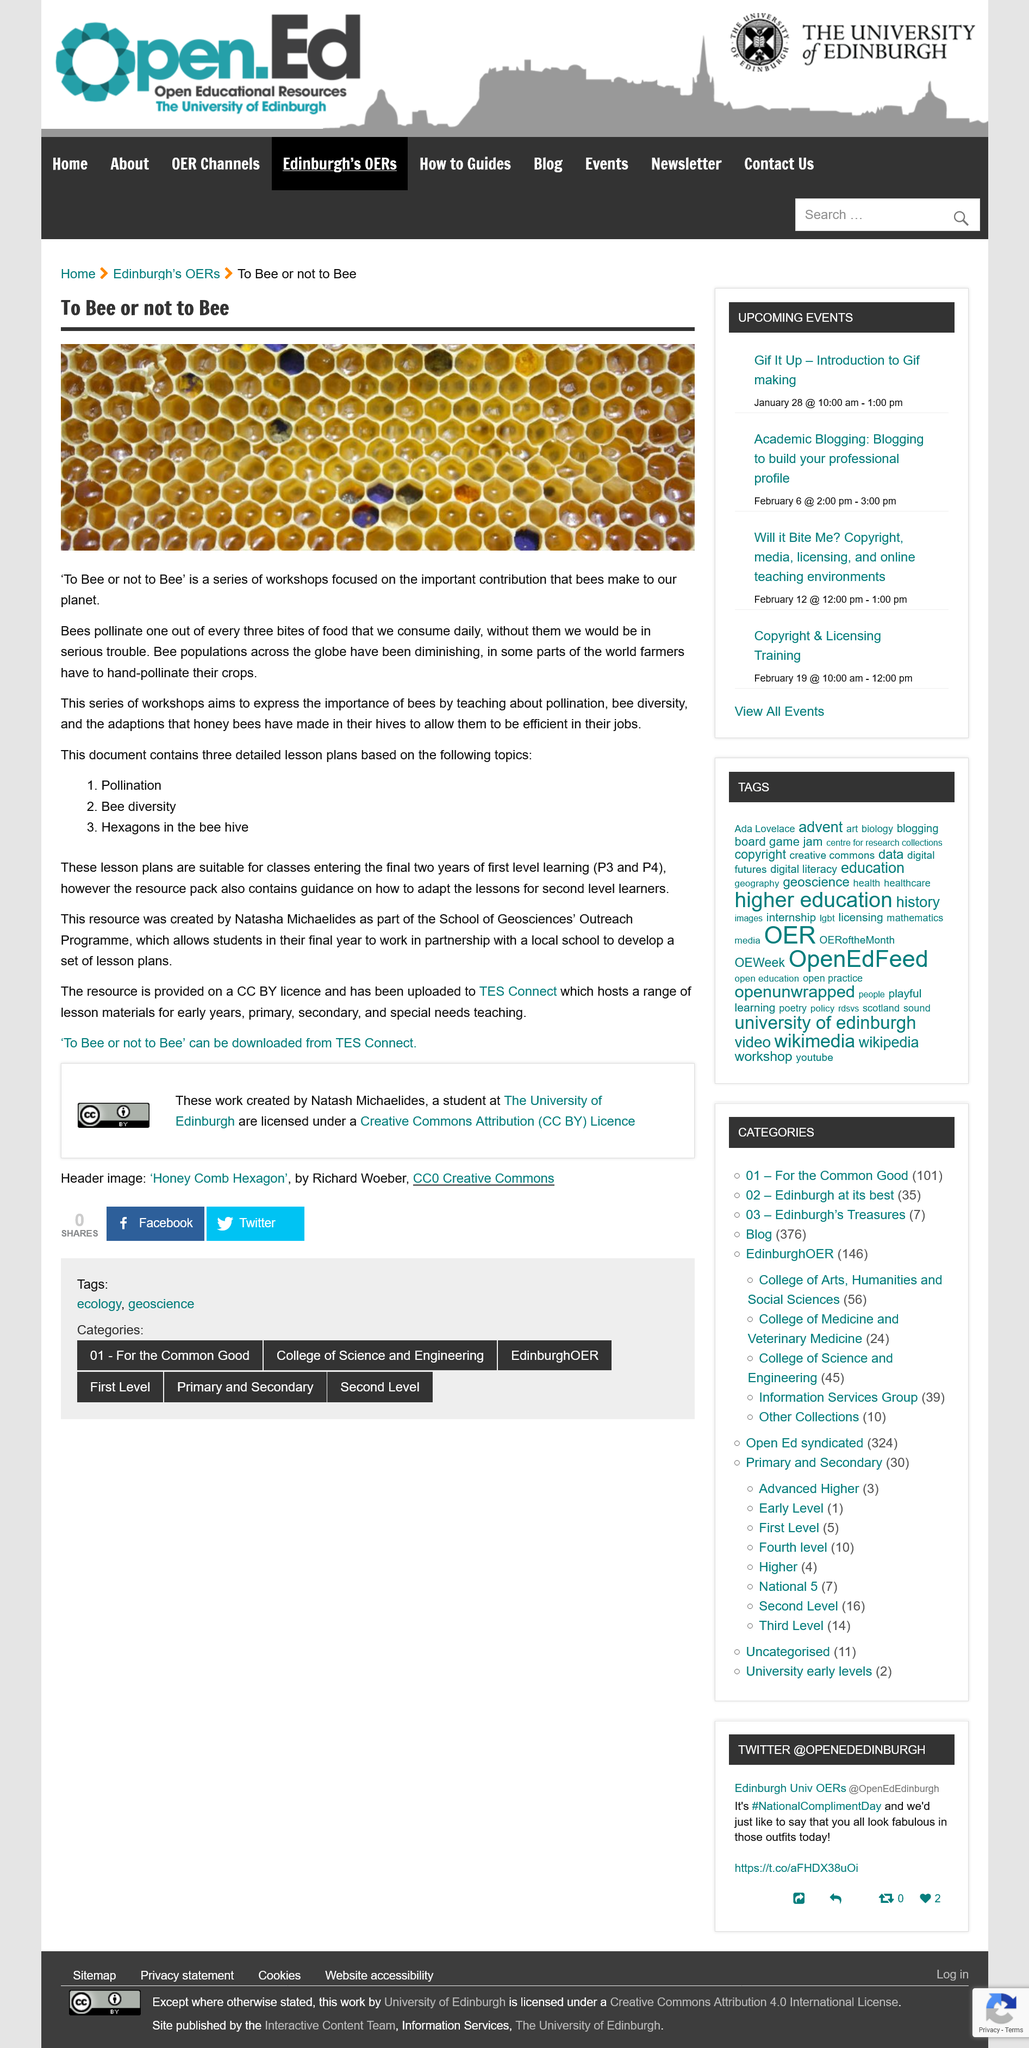Mention a couple of crucial points in this snapshot. The workshop aims to emphasize the vital importance of bees in our ecosystem, economy, and society. Pollination, bee diversity, and hexagons in the bee hive are among the topics that this text covers. The lesson plans are suitable for classes in the final two years of first-level learning, which corresponds to P3 and P4. Bee or not to bee, that is the question. Our workshops focus on the importance of bees and their vital contributions to our planet. The School of Geosciences' Outreach Programme is affiliated with The University of Edinburgh. 